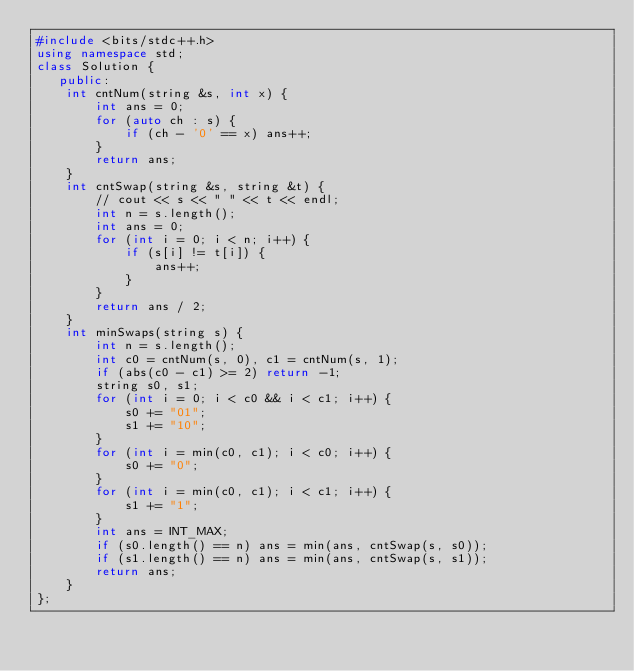<code> <loc_0><loc_0><loc_500><loc_500><_C++_>#include <bits/stdc++.h>
using namespace std;
class Solution {
   public:
    int cntNum(string &s, int x) {
        int ans = 0;
        for (auto ch : s) {
            if (ch - '0' == x) ans++;
        }
        return ans;
    }
    int cntSwap(string &s, string &t) {
        // cout << s << " " << t << endl;
        int n = s.length();
        int ans = 0;
        for (int i = 0; i < n; i++) {
            if (s[i] != t[i]) {
                ans++;
            }
        }
        return ans / 2;
    }
    int minSwaps(string s) {
        int n = s.length();
        int c0 = cntNum(s, 0), c1 = cntNum(s, 1);
        if (abs(c0 - c1) >= 2) return -1;
        string s0, s1;
        for (int i = 0; i < c0 && i < c1; i++) {
            s0 += "01";
            s1 += "10";
        }
        for (int i = min(c0, c1); i < c0; i++) {
            s0 += "0";
        }
        for (int i = min(c0, c1); i < c1; i++) {
            s1 += "1";
        }
        int ans = INT_MAX;
        if (s0.length() == n) ans = min(ans, cntSwap(s, s0));
        if (s1.length() == n) ans = min(ans, cntSwap(s, s1));
        return ans;
    }
};
</code> 